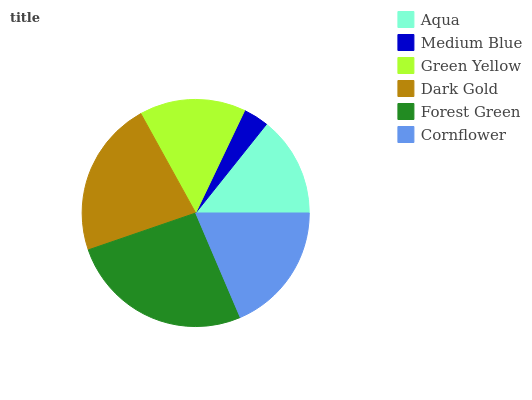Is Medium Blue the minimum?
Answer yes or no. Yes. Is Forest Green the maximum?
Answer yes or no. Yes. Is Green Yellow the minimum?
Answer yes or no. No. Is Green Yellow the maximum?
Answer yes or no. No. Is Green Yellow greater than Medium Blue?
Answer yes or no. Yes. Is Medium Blue less than Green Yellow?
Answer yes or no. Yes. Is Medium Blue greater than Green Yellow?
Answer yes or no. No. Is Green Yellow less than Medium Blue?
Answer yes or no. No. Is Cornflower the high median?
Answer yes or no. Yes. Is Green Yellow the low median?
Answer yes or no. Yes. Is Aqua the high median?
Answer yes or no. No. Is Forest Green the low median?
Answer yes or no. No. 